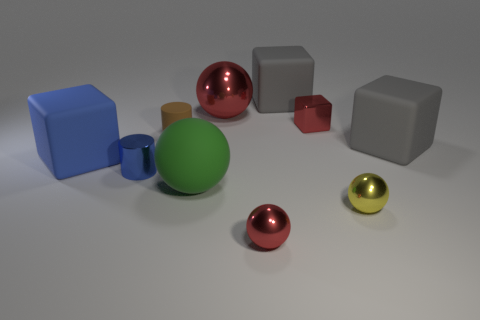Subtract all purple balls. Subtract all brown cylinders. How many balls are left? 4 Subtract all blocks. How many objects are left? 6 Add 7 purple rubber cubes. How many purple rubber cubes exist? 7 Subtract 0 cyan cylinders. How many objects are left? 10 Subtract all tiny cyan metallic cylinders. Subtract all large gray rubber cubes. How many objects are left? 8 Add 4 metal balls. How many metal balls are left? 7 